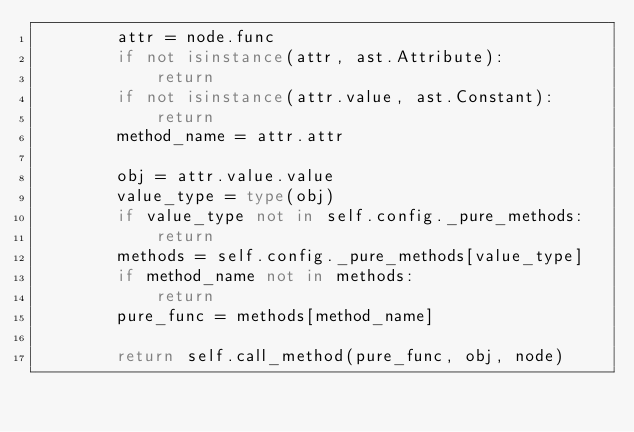Convert code to text. <code><loc_0><loc_0><loc_500><loc_500><_Python_>        attr = node.func
        if not isinstance(attr, ast.Attribute):
            return
        if not isinstance(attr.value, ast.Constant):
            return
        method_name = attr.attr

        obj = attr.value.value
        value_type = type(obj)
        if value_type not in self.config._pure_methods:
            return
        methods = self.config._pure_methods[value_type]
        if method_name not in methods:
            return
        pure_func = methods[method_name]

        return self.call_method(pure_func, obj, node)
</code> 